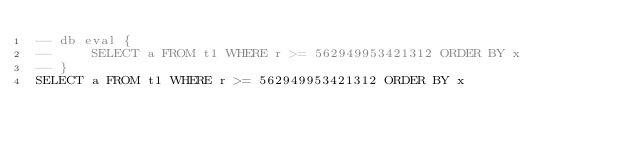<code> <loc_0><loc_0><loc_500><loc_500><_SQL_>-- db eval {
--     SELECT a FROM t1 WHERE r >= 562949953421312 ORDER BY x
-- }
SELECT a FROM t1 WHERE r >= 562949953421312 ORDER BY x</code> 